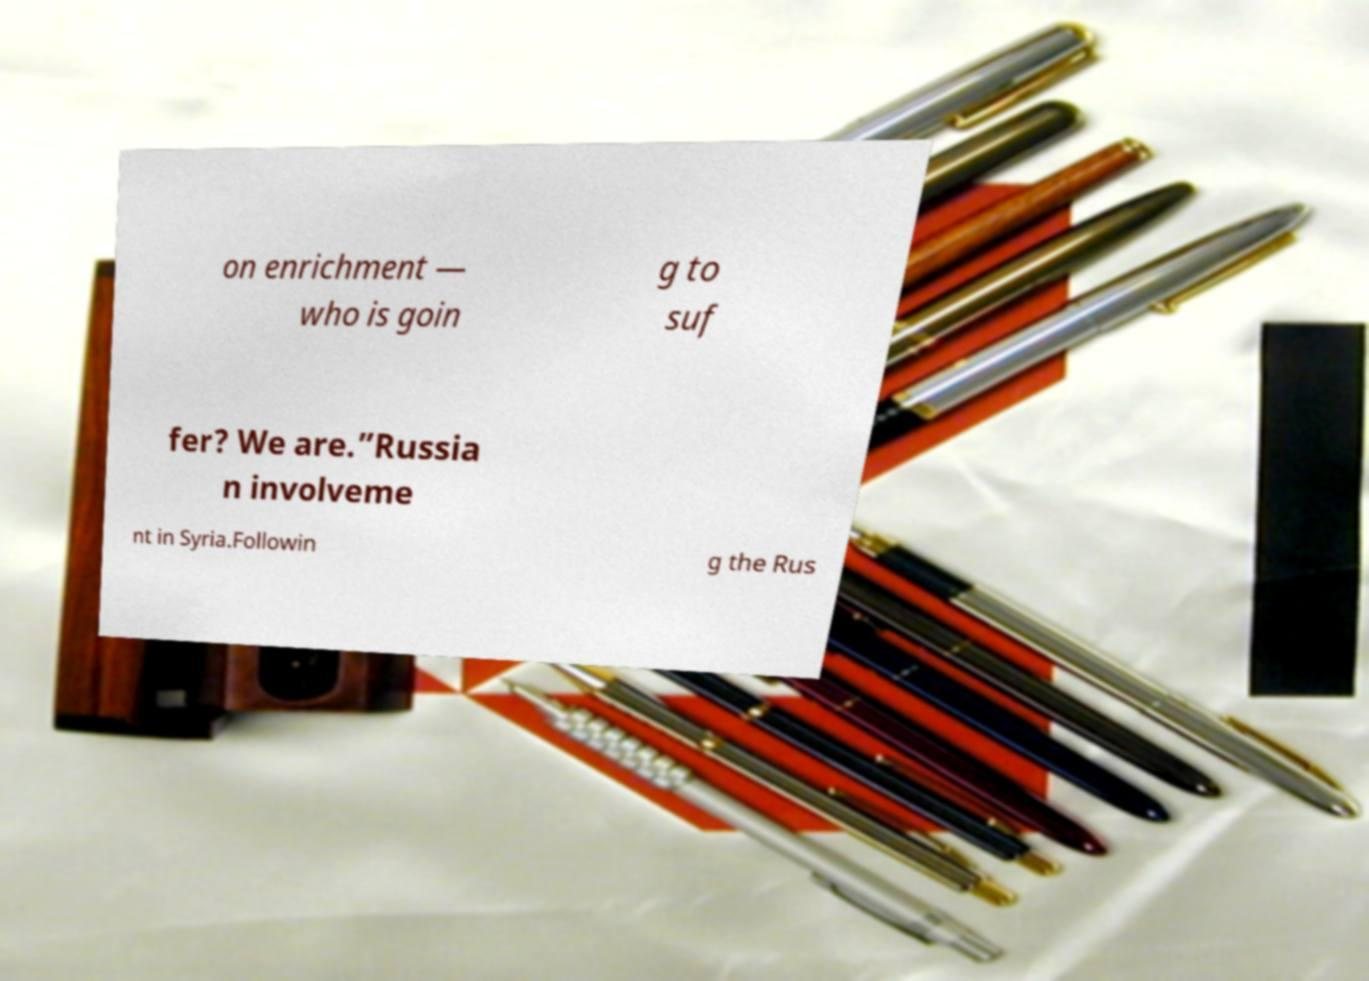I need the written content from this picture converted into text. Can you do that? on enrichment — who is goin g to suf fer? We are.”Russia n involveme nt in Syria.Followin g the Rus 